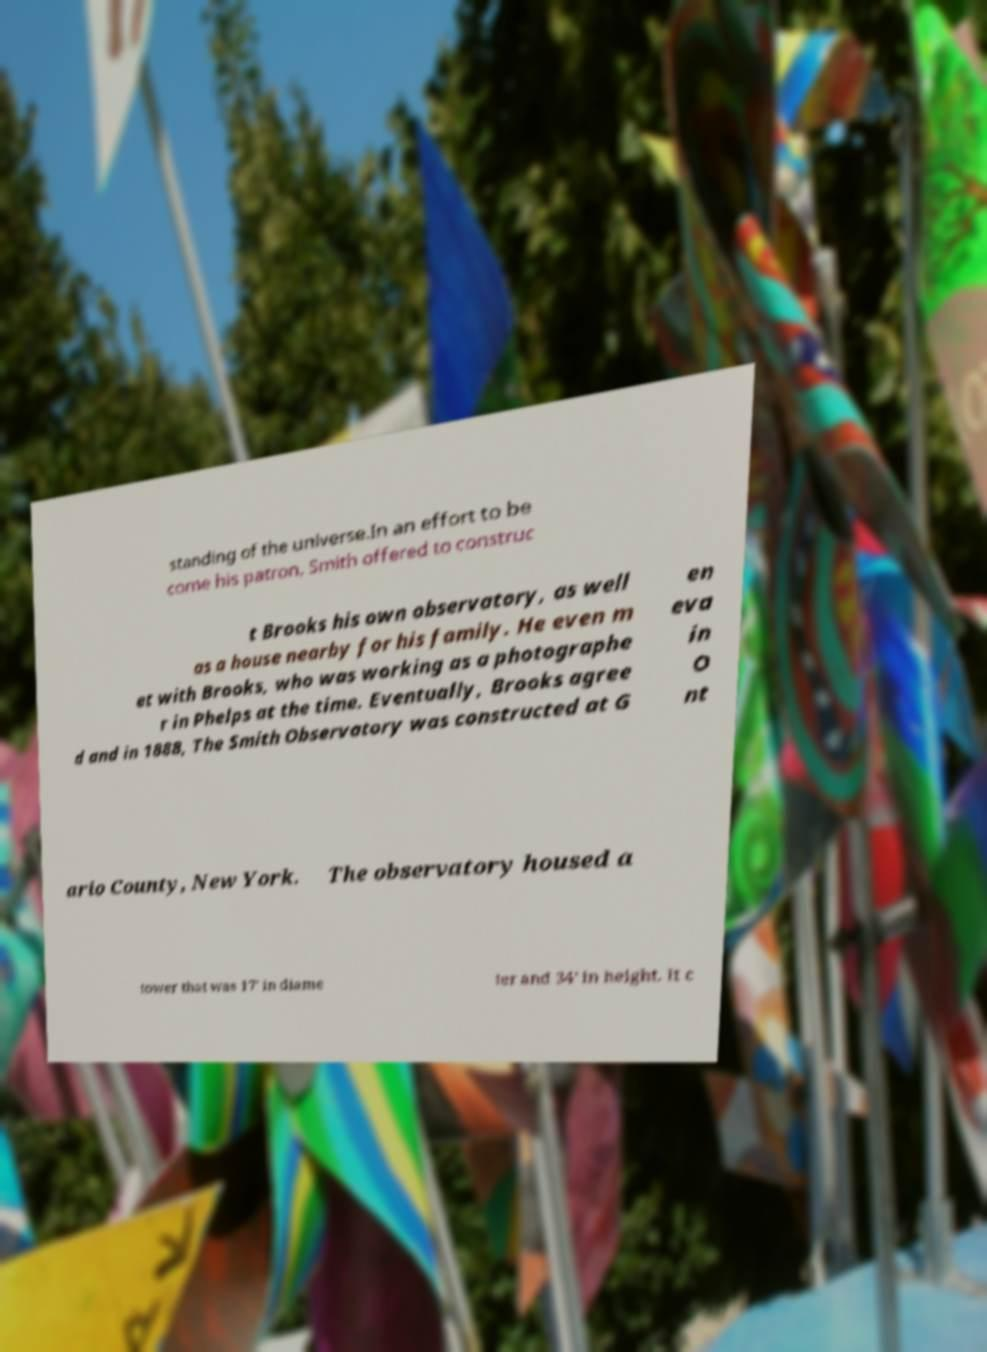Please read and relay the text visible in this image. What does it say? standing of the universe.In an effort to be come his patron, Smith offered to construc t Brooks his own observatory, as well as a house nearby for his family. He even m et with Brooks, who was working as a photographe r in Phelps at the time. Eventually, Brooks agree d and in 1888, The Smith Observatory was constructed at G en eva in O nt ario County, New York. The observatory housed a tower that was 17' in diame ter and 34' in height. It c 